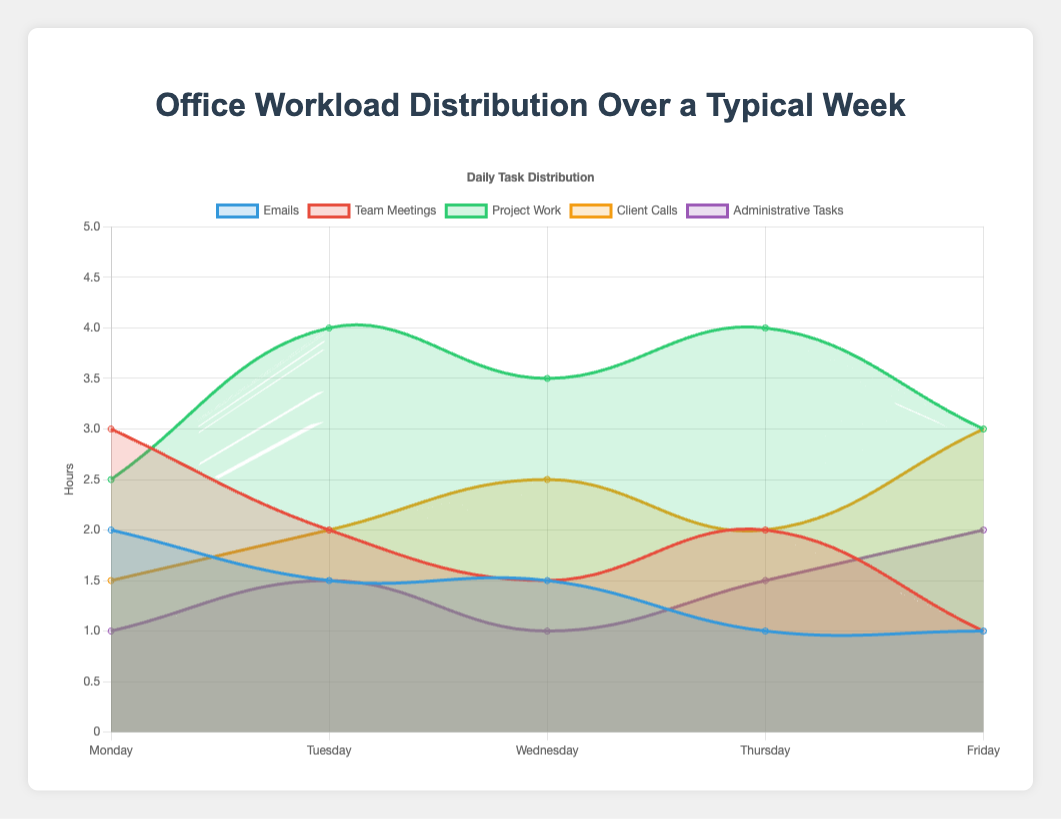What's the total number of hours spent on Project Work throughout the week? Sum the hours spent on Project Work for each weekday: 2.5 (Monday) + 4 (Tuesday) + 3.5 (Wednesday) + 4 (Thursday) + 3 (Friday) = 17 hours
Answer: 17 hours On which day is the least amount of time spent on Emails? Check and compare the hours spent on Emails each day: Monday (2), Tuesday (1.5), Wednesday (1.5), Thursday (1), Friday (1). Thus, Thursday and Friday are the least.
Answer: Thursday, Friday How does the time spent on Team Meetings on Friday compare to that on Monday? Note the hours spent on Team Meetings: Friday (1) and Monday (3). Hence, less time is spent on Friday.
Answer: Less time on Friday What is the highest amount of time spent on Client Calls on any given day? Compare the hours for Client Calls across all days: Monday (1.5), Tuesday (2), Wednesday (2.5), Thursday (2), Friday (3). Friday has the highest.
Answer: 3 hours How many more hours are spent on Administrative Tasks on Friday compared to Monday? Subtract Monday's hours from Friday's: 2 (Friday) - 1 (Monday) = 1 hour more
Answer: 1 hour Which task shows the most significant fluctuation in hours throughout the week? Observe the tasks: Emails (2, 1.5, 1.5, 1, 1), Team Meetings (3, 2, 1.5, 2, 1), Project Work (2.5, 4, 3.5, 4, 3), Client Calls (1.5, 2, 2.5, 2, 3), Administrative Tasks (1, 1.5, 1, 1.5, 2). Project Work and Client Calls show notable fluctuation.
Answer: Project Work, Client Calls Which visual color represents Client Calls on the chart? Identify the color associated with the Client Calls dataset in the chart's legend.
Answer: Orange On which day is the total number of hours worked the highest? Sum the total hours of all tasks for each day: Monday (10), Tuesday (11), Wednesday (10), Thursday (10.5), Friday (10). Tuesday has the highest at 11 hours.
Answer: Tuesday What is the average amount of time spent on Team Meetings throughout the week? Sum the hours and divide by the number of days: (3 + 2 + 1.5 + 2 + 1) / 5 = 1.9 hours
Answer: 1.9 hours 